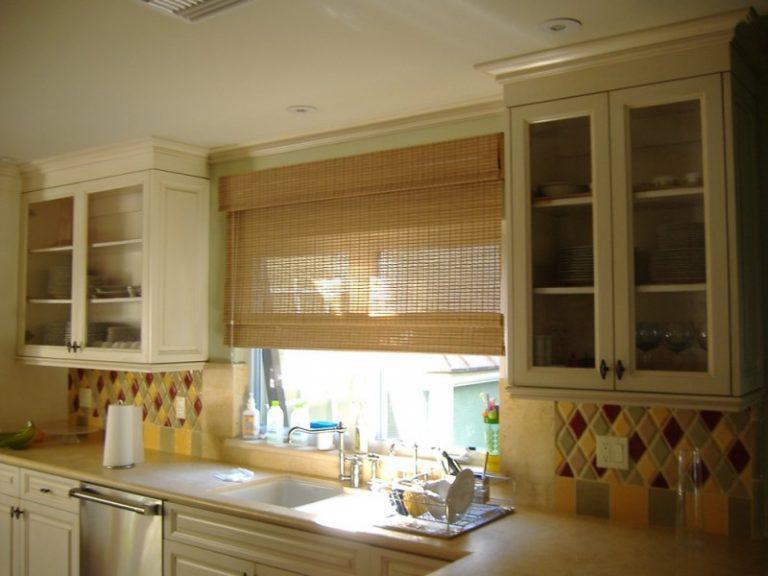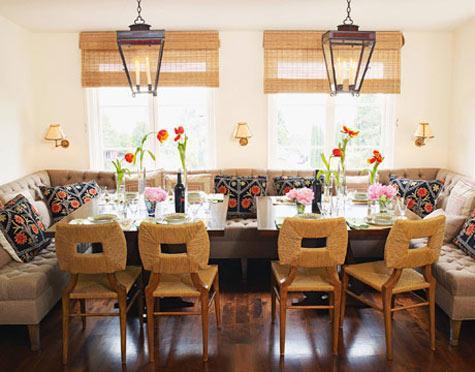The first image is the image on the left, the second image is the image on the right. For the images displayed, is the sentence "At least one shade is all the way closed." factually correct? Answer yes or no. No. The first image is the image on the left, the second image is the image on the right. Analyze the images presented: Is the assertion "There are six blinds." valid? Answer yes or no. No. 